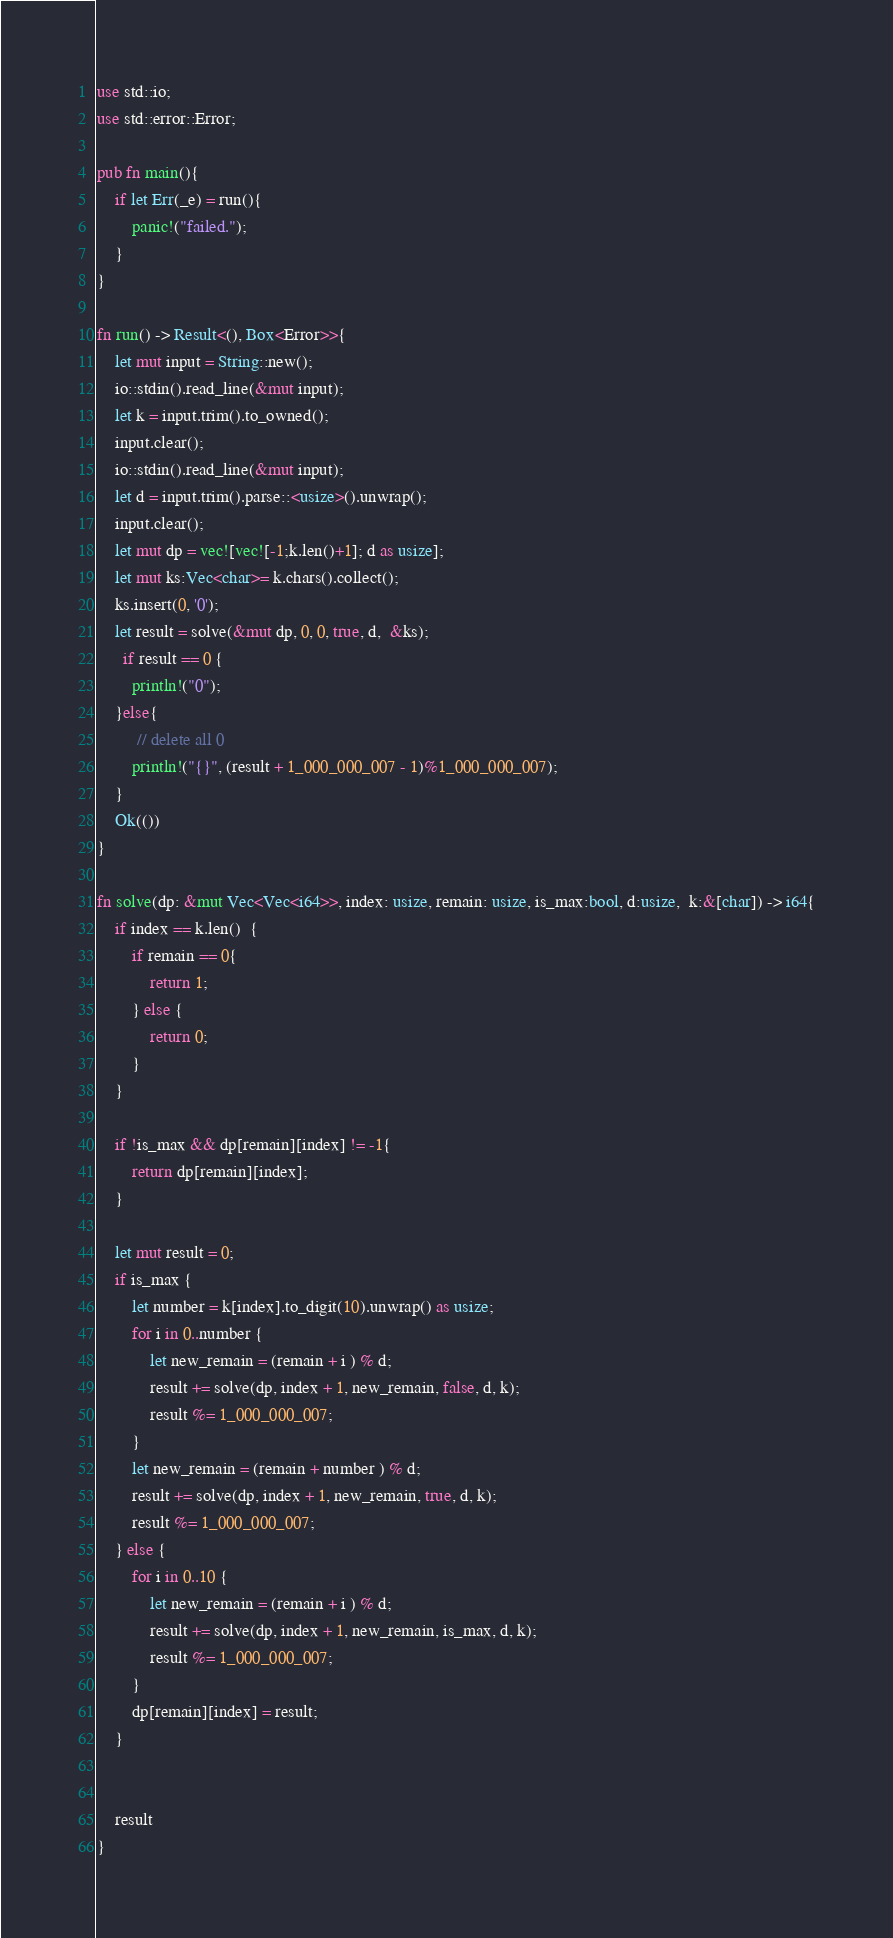<code> <loc_0><loc_0><loc_500><loc_500><_Rust_>use std::io;
use std::error::Error;

pub fn main(){
    if let Err(_e) = run(){
        panic!("failed.");
    }
}

fn run() -> Result<(), Box<Error>>{
    let mut input = String::new();
    io::stdin().read_line(&mut input);
    let k = input.trim().to_owned(); 
    input.clear();
    io::stdin().read_line(&mut input);
    let d = input.trim().parse::<usize>().unwrap();
    input.clear(); 
    let mut dp = vec![vec![-1;k.len()+1]; d as usize];
    let mut ks:Vec<char>= k.chars().collect();
    ks.insert(0, '0');
    let result = solve(&mut dp, 0, 0, true, d,  &ks);
      if result == 0 {
        println!("0"); 
    }else{
         // delete all 0
        println!("{}", (result + 1_000_000_007 - 1)%1_000_000_007);
    }
    Ok(())
}

fn solve(dp: &mut Vec<Vec<i64>>, index: usize, remain: usize, is_max:bool, d:usize,  k:&[char]) -> i64{
    if index == k.len()  {
        if remain == 0{
            return 1;
        } else {
            return 0;
        }
    }

    if !is_max && dp[remain][index] != -1{
        return dp[remain][index];
    }

    let mut result = 0;
    if is_max {
        let number = k[index].to_digit(10).unwrap() as usize; 
        for i in 0..number {
            let new_remain = (remain + i ) % d;
            result += solve(dp, index + 1, new_remain, false, d, k);
            result %= 1_000_000_007;
        }
        let new_remain = (remain + number ) % d;
        result += solve(dp, index + 1, new_remain, true, d, k);
        result %= 1_000_000_007;
    } else {
        for i in 0..10 {
            let new_remain = (remain + i ) % d;
            result += solve(dp, index + 1, new_remain, is_max, d, k);
            result %= 1_000_000_007;
        }
        dp[remain][index] = result;
    }
    

    result
}

</code> 